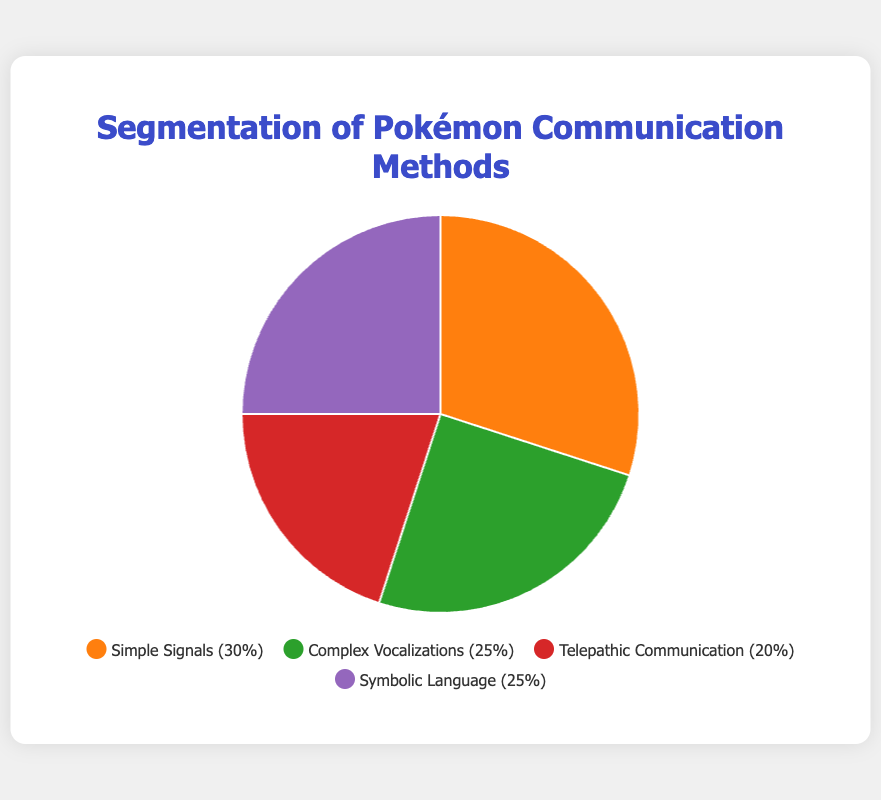Which communication method is the most frequently used among Pokémon? The communication method with the highest percentage represents the most frequently used method. Here, Simple Signals is the highest at 30%.
Answer: Simple Signals What percentage do Complex Vocalizations and Symbolic Language together represent? To find the combined percentage, add the percentages of Complex Vocalizations (25%) and Symbolic Language (25%).
Answer: 50% Which communication methods have the same percentage of usage among Pokémon? From the pie chart, Complex Vocalizations and Symbolic Language both have a percentage of 25%.
Answer: Complex Vocalizations and Symbolic Language What is the difference in usage percentage between Telepathic Communication and Simple Signals? Subtract the percentage of Telepathic Communication (20%) from Simple Signals (30%), resulting in a difference of 10%.
Answer: 10% Arrange the communication methods in descending order of their usage complexity. From the descriptions: Symbolic Language (most complex), Telepathic Communication, Complex Vocalizations, Simple Signals (least complex).
Answer: Symbolic Language, Telepathic Communication, Complex Vocalizations, Simple Signals What is the average percentage of usage across all communication methods? Sum up all the percentages (30% + 25% + 20% + 25%) to get 100%. Then divide by the number of methods, which is 4. The average is 100% / 4 = 25%.
Answer: 25% Is Telepathic Communication used more or less than both Complex Vocalizations and Symbolic Language? Telepathic Communication is 20%, while both Complex Vocalizations and Symbolic Language are 25%. Therefore, it is used less.
Answer: Less If 1000 Pokémon are surveyed, approximately how many use Symbolic Language? Symbolic Language is used by 25% of Pokémon. Therefore, 25% of 1000 Pokémon equals 250.
Answer: 250 Which communication method uses the color green in the pie chart? The pie chart uses the color green for Complex Vocalizations (25%).
Answer: Complex Vocalizations What percentage of Pokémon do not use either Simple Signals or Telepathic Communication? Subtract the combined percentage of Simple Signals (30%) and Telepathic Communication (20%) from 100%, resulting in 100% - 50% = 50%.
Answer: 50% 